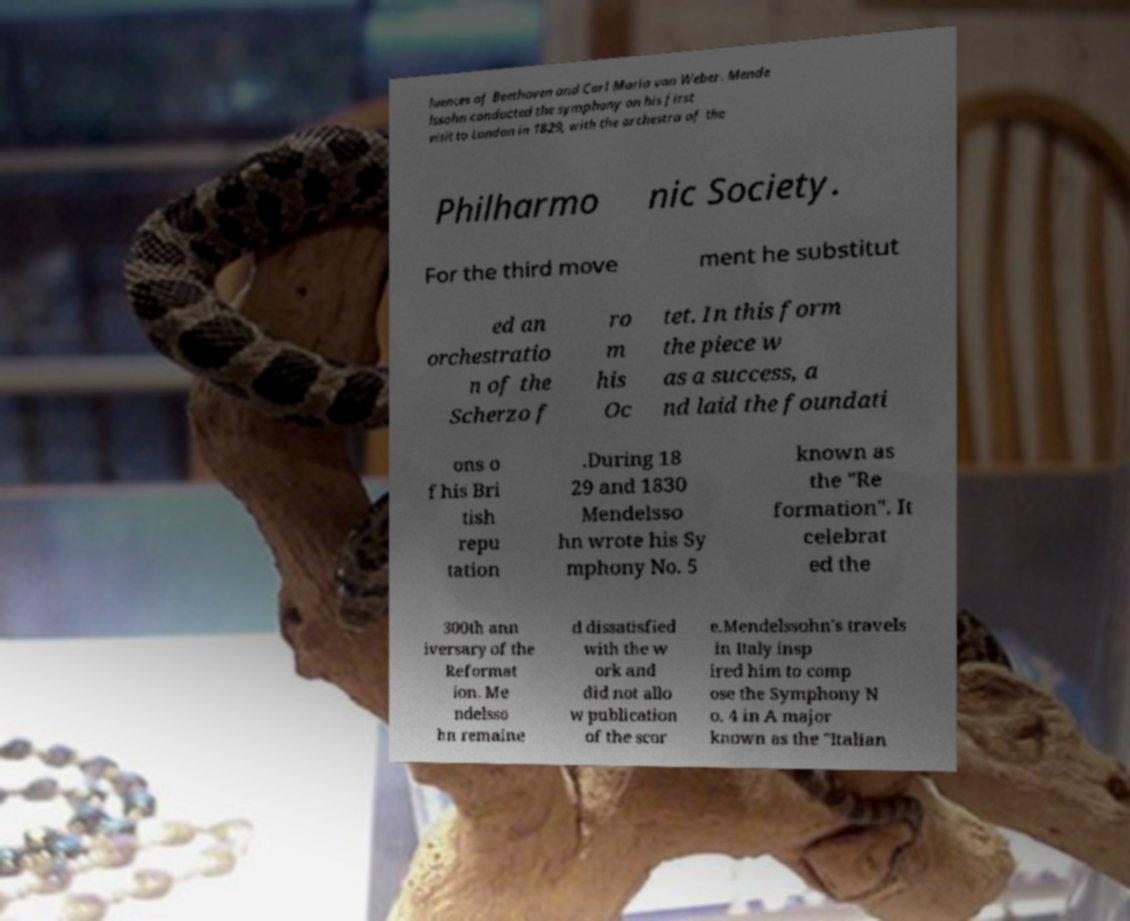I need the written content from this picture converted into text. Can you do that? luences of Beethoven and Carl Maria von Weber. Mende lssohn conducted the symphony on his first visit to London in 1829, with the orchestra of the Philharmo nic Society. For the third move ment he substitut ed an orchestratio n of the Scherzo f ro m his Oc tet. In this form the piece w as a success, a nd laid the foundati ons o f his Bri tish repu tation .During 18 29 and 1830 Mendelsso hn wrote his Sy mphony No. 5 known as the "Re formation". It celebrat ed the 300th ann iversary of the Reformat ion. Me ndelsso hn remaine d dissatisfied with the w ork and did not allo w publication of the scor e.Mendelssohn's travels in Italy insp ired him to comp ose the Symphony N o. 4 in A major known as the "Italian 